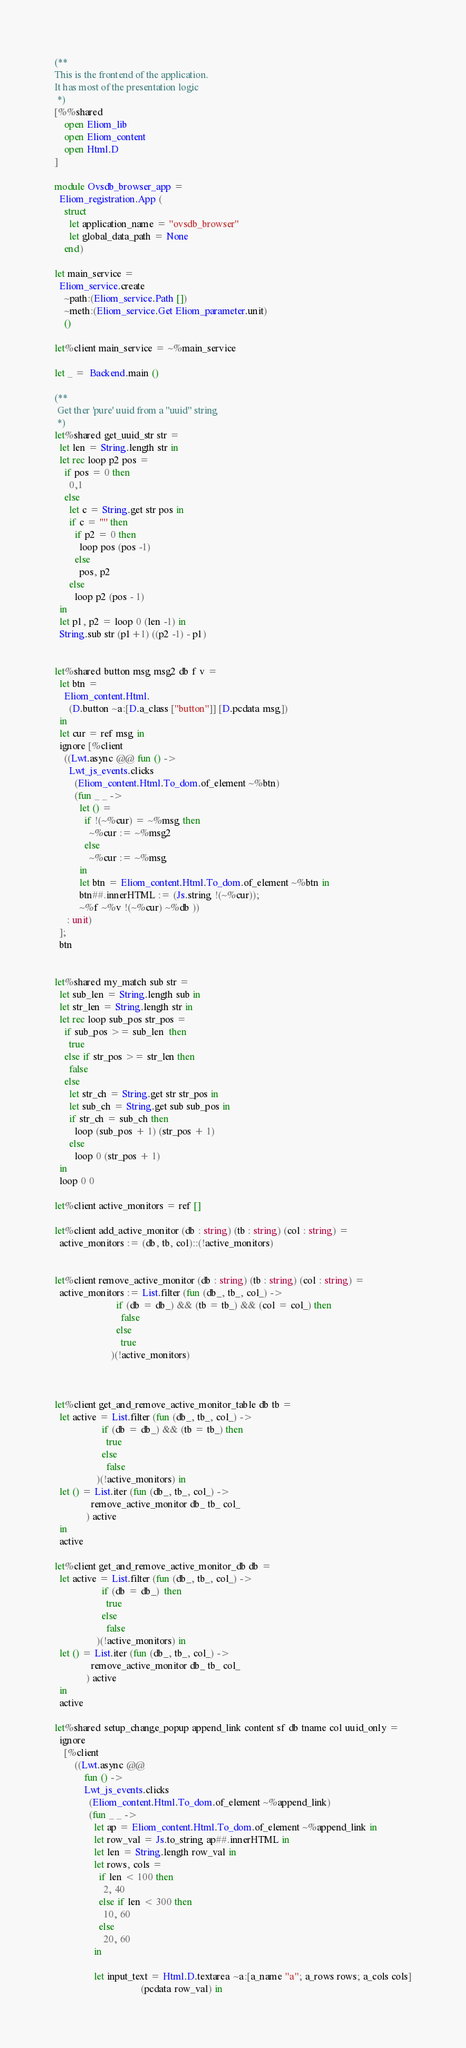<code> <loc_0><loc_0><loc_500><loc_500><_OCaml_>(**
This is the frontend of the application.
It has most of the presentation logic
 *)
[%%shared
    open Eliom_lib
    open Eliom_content
    open Html.D
]

module Ovsdb_browser_app =
  Eliom_registration.App (
    struct
      let application_name = "ovsdb_browser"
      let global_data_path = None
    end)

let main_service =
  Eliom_service.create
    ~path:(Eliom_service.Path [])
    ~meth:(Eliom_service.Get Eliom_parameter.unit)
    ()

let%client main_service = ~%main_service

let _ =  Backend.main ()

(**
 Get ther 'pure' uuid from a "uuid" string
 *)
let%shared get_uuid_str str =
  let len = String.length str in
  let rec loop p2 pos =
    if pos = 0 then
      0,1
    else
      let c = String.get str pos in
      if c = '"' then
        if p2 = 0 then
          loop pos (pos -1)
        else
          pos, p2
      else
        loop p2 (pos - 1)
  in
  let p1, p2 = loop 0 (len -1) in
  String.sub str (p1+1) ((p2 -1) - p1)


let%shared button msg msg2 db f v =
  let btn =
    Eliom_content.Html.
      (D.button ~a:[D.a_class ["button"]] [D.pcdata msg])
  in
  let cur = ref msg in
  ignore [%client
    ((Lwt.async @@ fun () ->
      Lwt_js_events.clicks
        (Eliom_content.Html.To_dom.of_element ~%btn)
        (fun _ _ ->
          let () =
            if !(~%cur) = ~%msg then
              ~%cur := ~%msg2
            else
              ~%cur := ~%msg
          in
          let btn = Eliom_content.Html.To_dom.of_element ~%btn in
          btn##.innerHTML := (Js.string !(~%cur));
          ~%f ~%v !(~%cur) ~%db ))
     : unit)
  ];
  btn


let%shared my_match sub str =
  let sub_len = String.length sub in
  let str_len = String.length str in
  let rec loop sub_pos str_pos =
    if sub_pos >= sub_len  then
      true
    else if str_pos >= str_len then
      false
    else
      let str_ch = String.get str str_pos in
      let sub_ch = String.get sub sub_pos in
      if str_ch = sub_ch then
        loop (sub_pos + 1) (str_pos + 1)
      else
        loop 0 (str_pos + 1)
  in
  loop 0 0

let%client active_monitors = ref []

let%client add_active_monitor (db : string) (tb : string) (col : string) =
  active_monitors := (db, tb, col)::(!active_monitors)


let%client remove_active_monitor (db : string) (tb : string) (col : string) =
  active_monitors := List.filter (fun (db_, tb_, col_) ->
                         if (db = db_) && (tb = tb_) && (col = col_) then
                           false
                         else
                           true
                       )(!active_monitors)



let%client get_and_remove_active_monitor_table db tb =
  let active = List.filter (fun (db_, tb_, col_) ->
                   if (db = db_) && (tb = tb_) then
                     true
                   else
                     false
                 )(!active_monitors) in
  let () = List.iter (fun (db_, tb_, col_) ->
               remove_active_monitor db_ tb_ col_
             ) active
  in
  active

let%client get_and_remove_active_monitor_db db =
  let active = List.filter (fun (db_, tb_, col_) ->
                   if (db = db_)  then
                     true
                   else
                     false
                 )(!active_monitors) in
  let () = List.iter (fun (db_, tb_, col_) ->
               remove_active_monitor db_ tb_ col_
             ) active
  in
  active

let%shared setup_change_popup append_link content sf db tname col uuid_only =
  ignore
    [%client
        ((Lwt.async @@
            fun () ->
            Lwt_js_events.clicks
              (Eliom_content.Html.To_dom.of_element ~%append_link)
              (fun _ _ ->
                let ap = Eliom_content.Html.To_dom.of_element ~%append_link in
                let row_val = Js.to_string ap##.innerHTML in
                let len = String.length row_val in
                let rows, cols =
                  if len < 100 then
                    2, 40
                  else if len < 300 then
                    10, 60
                  else
                    20, 60
                in

                let input_text = Html.D.textarea ~a:[a_name "a"; a_rows rows; a_cols cols]
                                   (pcdata row_val) in</code> 